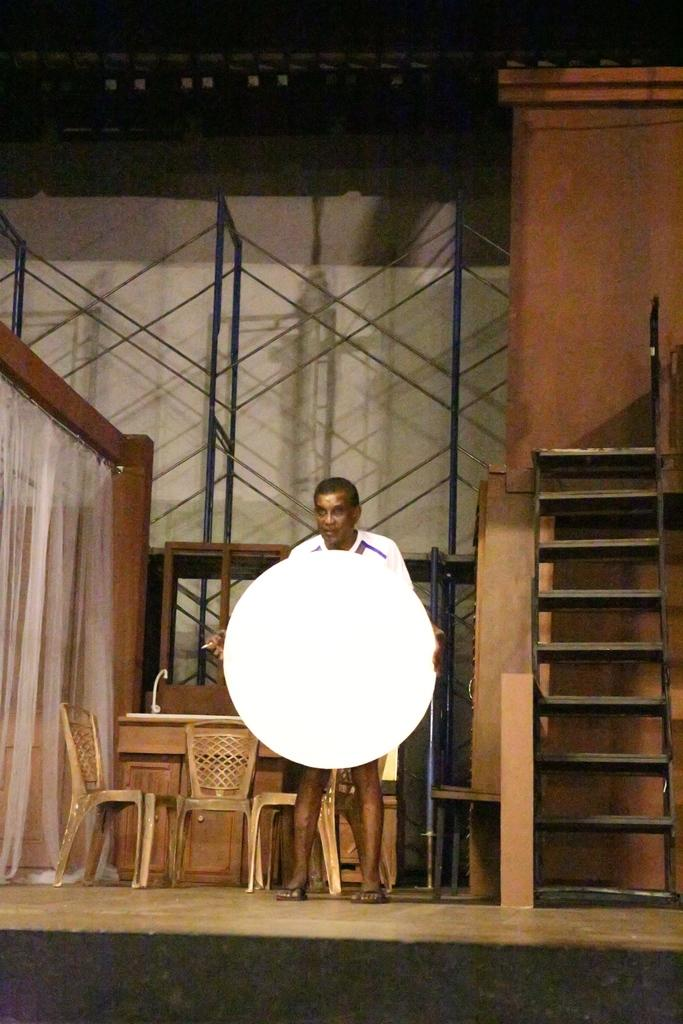What is the man in the image doing? The man is standing in the image. What is the man holding in the image? The man is holding a white, circular object. What type of furniture can be seen in the image? There are chairs in the image. What architectural feature is present in the image? There are stairs in the image. What is another piece of furniture present in the image? There is a table in the image. How many horses are present in the image? There are no horses present in the image. What level of regret is the man experiencing in the image? There is no indication of the man's emotions or feelings in the image, so it is not possible to determine his level of regret. 